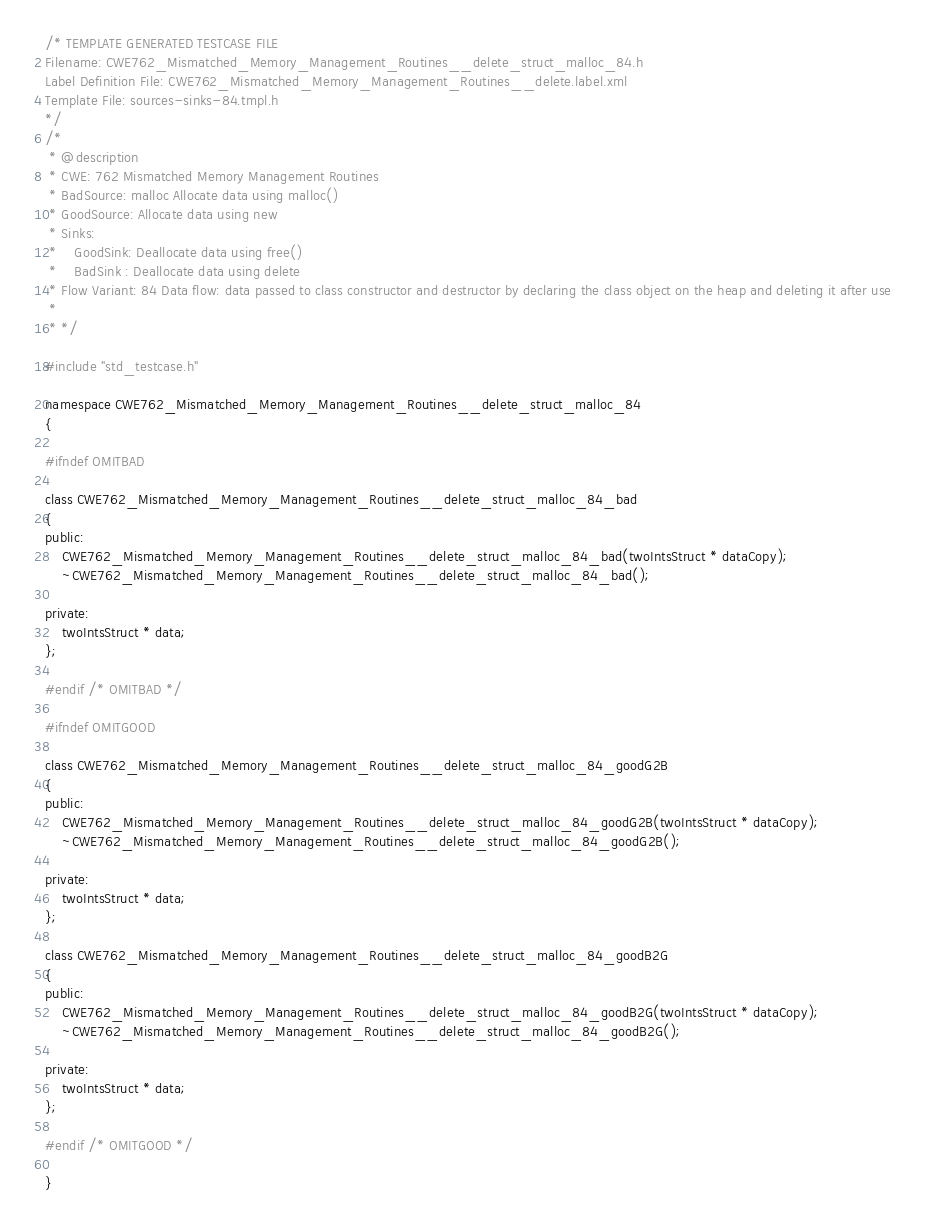Convert code to text. <code><loc_0><loc_0><loc_500><loc_500><_C_>/* TEMPLATE GENERATED TESTCASE FILE
Filename: CWE762_Mismatched_Memory_Management_Routines__delete_struct_malloc_84.h
Label Definition File: CWE762_Mismatched_Memory_Management_Routines__delete.label.xml
Template File: sources-sinks-84.tmpl.h
*/
/*
 * @description
 * CWE: 762 Mismatched Memory Management Routines
 * BadSource: malloc Allocate data using malloc()
 * GoodSource: Allocate data using new
 * Sinks:
 *    GoodSink: Deallocate data using free()
 *    BadSink : Deallocate data using delete
 * Flow Variant: 84 Data flow: data passed to class constructor and destructor by declaring the class object on the heap and deleting it after use
 *
 * */

#include "std_testcase.h"

namespace CWE762_Mismatched_Memory_Management_Routines__delete_struct_malloc_84
{

#ifndef OMITBAD

class CWE762_Mismatched_Memory_Management_Routines__delete_struct_malloc_84_bad
{
public:
    CWE762_Mismatched_Memory_Management_Routines__delete_struct_malloc_84_bad(twoIntsStruct * dataCopy);
    ~CWE762_Mismatched_Memory_Management_Routines__delete_struct_malloc_84_bad();

private:
    twoIntsStruct * data;
};

#endif /* OMITBAD */

#ifndef OMITGOOD

class CWE762_Mismatched_Memory_Management_Routines__delete_struct_malloc_84_goodG2B
{
public:
    CWE762_Mismatched_Memory_Management_Routines__delete_struct_malloc_84_goodG2B(twoIntsStruct * dataCopy);
    ~CWE762_Mismatched_Memory_Management_Routines__delete_struct_malloc_84_goodG2B();

private:
    twoIntsStruct * data;
};

class CWE762_Mismatched_Memory_Management_Routines__delete_struct_malloc_84_goodB2G
{
public:
    CWE762_Mismatched_Memory_Management_Routines__delete_struct_malloc_84_goodB2G(twoIntsStruct * dataCopy);
    ~CWE762_Mismatched_Memory_Management_Routines__delete_struct_malloc_84_goodB2G();

private:
    twoIntsStruct * data;
};

#endif /* OMITGOOD */

}
</code> 